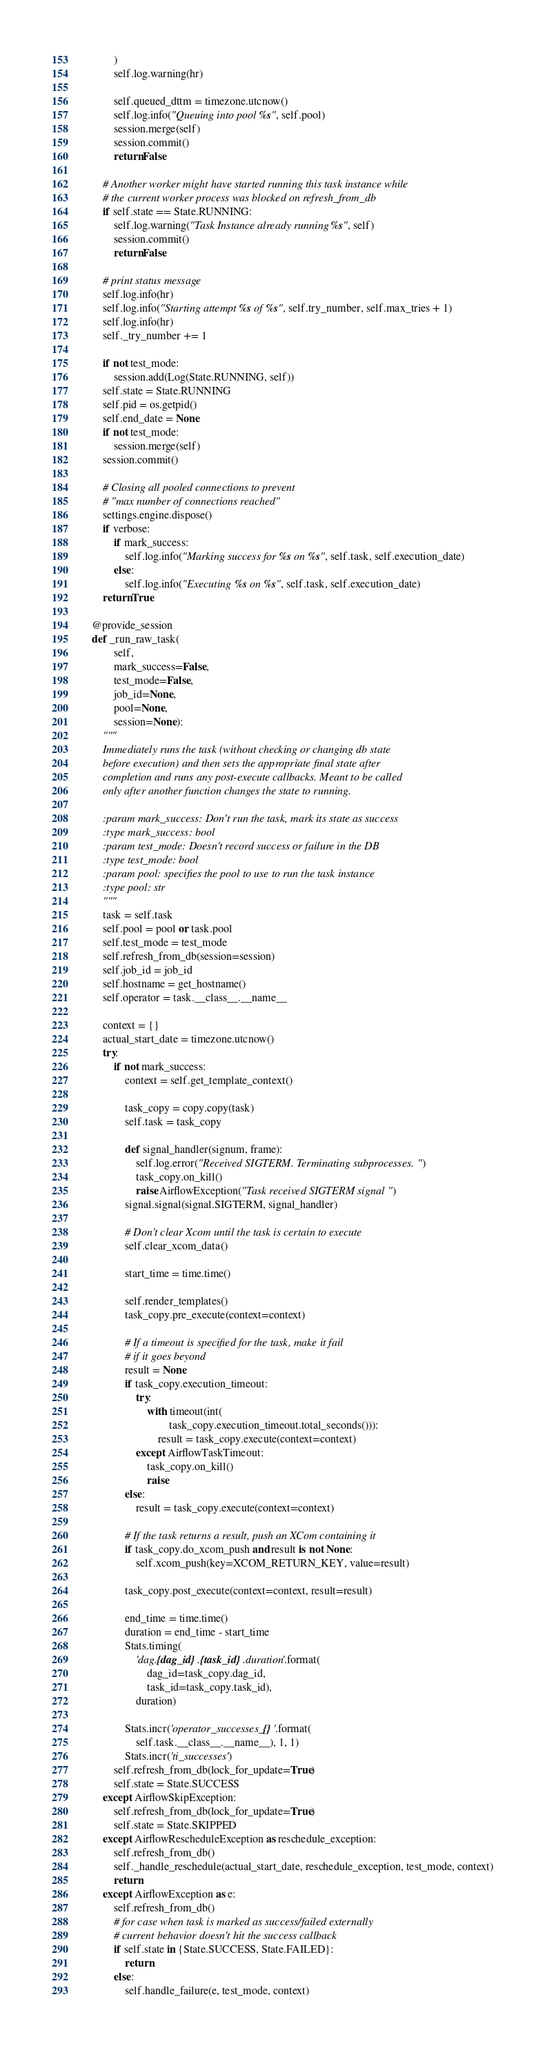<code> <loc_0><loc_0><loc_500><loc_500><_Python_>            )
            self.log.warning(hr)

            self.queued_dttm = timezone.utcnow()
            self.log.info("Queuing into pool %s", self.pool)
            session.merge(self)
            session.commit()
            return False

        # Another worker might have started running this task instance while
        # the current worker process was blocked on refresh_from_db
        if self.state == State.RUNNING:
            self.log.warning("Task Instance already running %s", self)
            session.commit()
            return False

        # print status message
        self.log.info(hr)
        self.log.info("Starting attempt %s of %s", self.try_number, self.max_tries + 1)
        self.log.info(hr)
        self._try_number += 1

        if not test_mode:
            session.add(Log(State.RUNNING, self))
        self.state = State.RUNNING
        self.pid = os.getpid()
        self.end_date = None
        if not test_mode:
            session.merge(self)
        session.commit()

        # Closing all pooled connections to prevent
        # "max number of connections reached"
        settings.engine.dispose()
        if verbose:
            if mark_success:
                self.log.info("Marking success for %s on %s", self.task, self.execution_date)
            else:
                self.log.info("Executing %s on %s", self.task, self.execution_date)
        return True

    @provide_session
    def _run_raw_task(
            self,
            mark_success=False,
            test_mode=False,
            job_id=None,
            pool=None,
            session=None):
        """
        Immediately runs the task (without checking or changing db state
        before execution) and then sets the appropriate final state after
        completion and runs any post-execute callbacks. Meant to be called
        only after another function changes the state to running.

        :param mark_success: Don't run the task, mark its state as success
        :type mark_success: bool
        :param test_mode: Doesn't record success or failure in the DB
        :type test_mode: bool
        :param pool: specifies the pool to use to run the task instance
        :type pool: str
        """
        task = self.task
        self.pool = pool or task.pool
        self.test_mode = test_mode
        self.refresh_from_db(session=session)
        self.job_id = job_id
        self.hostname = get_hostname()
        self.operator = task.__class__.__name__

        context = {}
        actual_start_date = timezone.utcnow()
        try:
            if not mark_success:
                context = self.get_template_context()

                task_copy = copy.copy(task)
                self.task = task_copy

                def signal_handler(signum, frame):
                    self.log.error("Received SIGTERM. Terminating subprocesses.")
                    task_copy.on_kill()
                    raise AirflowException("Task received SIGTERM signal")
                signal.signal(signal.SIGTERM, signal_handler)

                # Don't clear Xcom until the task is certain to execute
                self.clear_xcom_data()

                start_time = time.time()

                self.render_templates()
                task_copy.pre_execute(context=context)

                # If a timeout is specified for the task, make it fail
                # if it goes beyond
                result = None
                if task_copy.execution_timeout:
                    try:
                        with timeout(int(
                                task_copy.execution_timeout.total_seconds())):
                            result = task_copy.execute(context=context)
                    except AirflowTaskTimeout:
                        task_copy.on_kill()
                        raise
                else:
                    result = task_copy.execute(context=context)

                # If the task returns a result, push an XCom containing it
                if task_copy.do_xcom_push and result is not None:
                    self.xcom_push(key=XCOM_RETURN_KEY, value=result)

                task_copy.post_execute(context=context, result=result)

                end_time = time.time()
                duration = end_time - start_time
                Stats.timing(
                    'dag.{dag_id}.{task_id}.duration'.format(
                        dag_id=task_copy.dag_id,
                        task_id=task_copy.task_id),
                    duration)

                Stats.incr('operator_successes_{}'.format(
                    self.task.__class__.__name__), 1, 1)
                Stats.incr('ti_successes')
            self.refresh_from_db(lock_for_update=True)
            self.state = State.SUCCESS
        except AirflowSkipException:
            self.refresh_from_db(lock_for_update=True)
            self.state = State.SKIPPED
        except AirflowRescheduleException as reschedule_exception:
            self.refresh_from_db()
            self._handle_reschedule(actual_start_date, reschedule_exception, test_mode, context)
            return
        except AirflowException as e:
            self.refresh_from_db()
            # for case when task is marked as success/failed externally
            # current behavior doesn't hit the success callback
            if self.state in {State.SUCCESS, State.FAILED}:
                return
            else:
                self.handle_failure(e, test_mode, context)</code> 